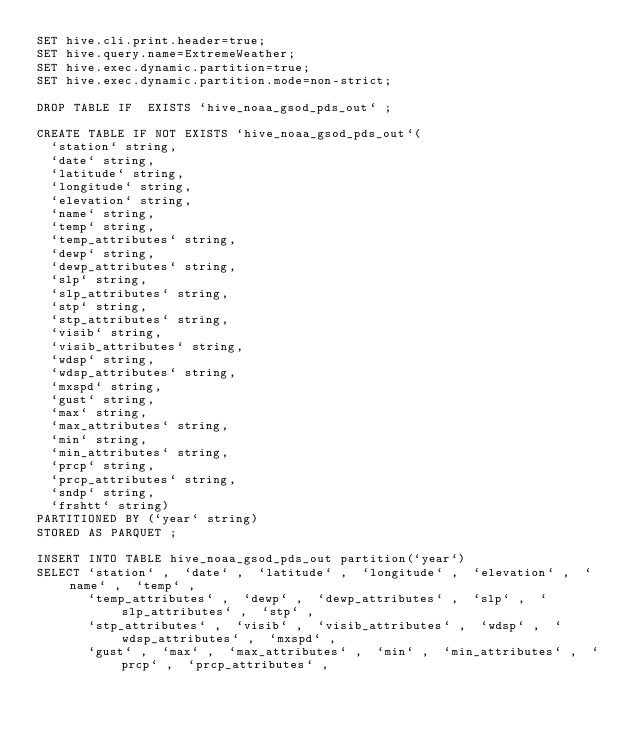<code> <loc_0><loc_0><loc_500><loc_500><_SQL_>SET hive.cli.print.header=true;
SET hive.query.name=ExtremeWeather;
SET hive.exec.dynamic.partition=true;
SET hive.exec.dynamic.partition.mode=non-strict;

DROP TABLE IF  EXISTS `hive_noaa_gsod_pds_out` ;

CREATE TABLE IF NOT EXISTS `hive_noaa_gsod_pds_out`(
  `station` string,
  `date` string,
  `latitude` string,
  `longitude` string,
  `elevation` string,
  `name` string,
  `temp` string,
  `temp_attributes` string,
  `dewp` string,
  `dewp_attributes` string,
  `slp` string,
  `slp_attributes` string,
  `stp` string,
  `stp_attributes` string,
  `visib` string,
  `visib_attributes` string,
  `wdsp` string,
  `wdsp_attributes` string,
  `mxspd` string,
  `gust` string,
  `max` string,
  `max_attributes` string,
  `min` string,
  `min_attributes` string,
  `prcp` string,
  `prcp_attributes` string,
  `sndp` string,
  `frshtt` string)
PARTITIONED BY (`year` string)
STORED AS PARQUET ;

INSERT INTO TABLE hive_noaa_gsod_pds_out partition(`year`)
SELECT `station` ,  `date` ,  `latitude` ,  `longitude` ,  `elevation` ,  `name` ,  `temp` ,
       `temp_attributes` ,  `dewp` ,  `dewp_attributes` ,  `slp` ,  `slp_attributes` ,  `stp` ,
       `stp_attributes` ,  `visib` ,  `visib_attributes` ,  `wdsp` ,  `wdsp_attributes` ,  `mxspd` ,
       `gust` ,  `max` ,  `max_attributes` ,  `min` ,  `min_attributes` ,  `prcp` ,  `prcp_attributes` ,</code> 